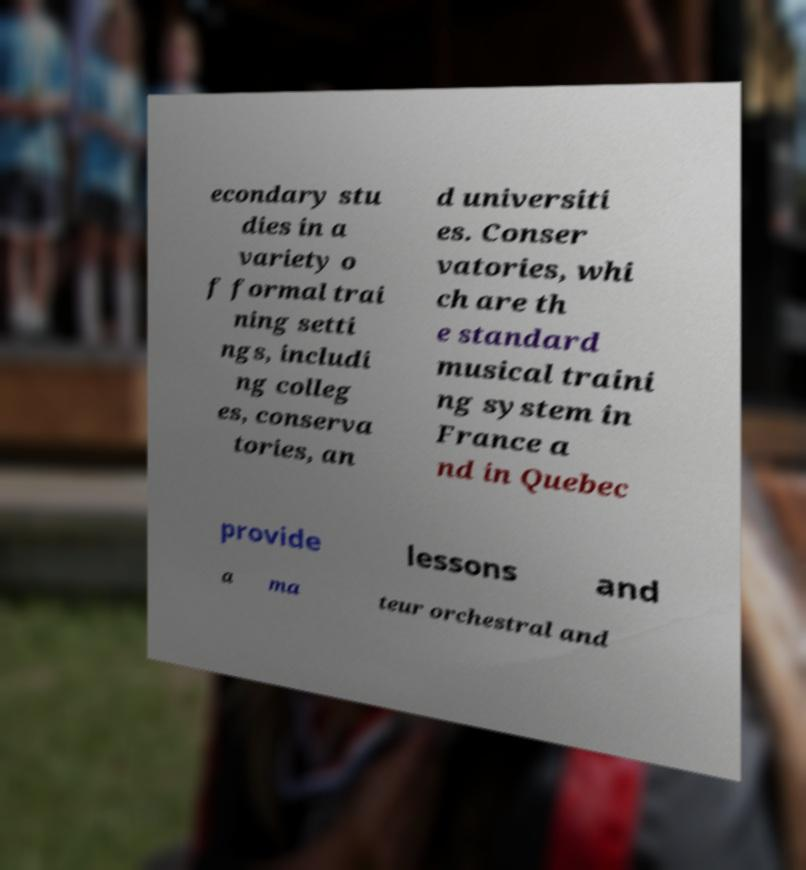Please read and relay the text visible in this image. What does it say? econdary stu dies in a variety o f formal trai ning setti ngs, includi ng colleg es, conserva tories, an d universiti es. Conser vatories, whi ch are th e standard musical traini ng system in France a nd in Quebec provide lessons and a ma teur orchestral and 